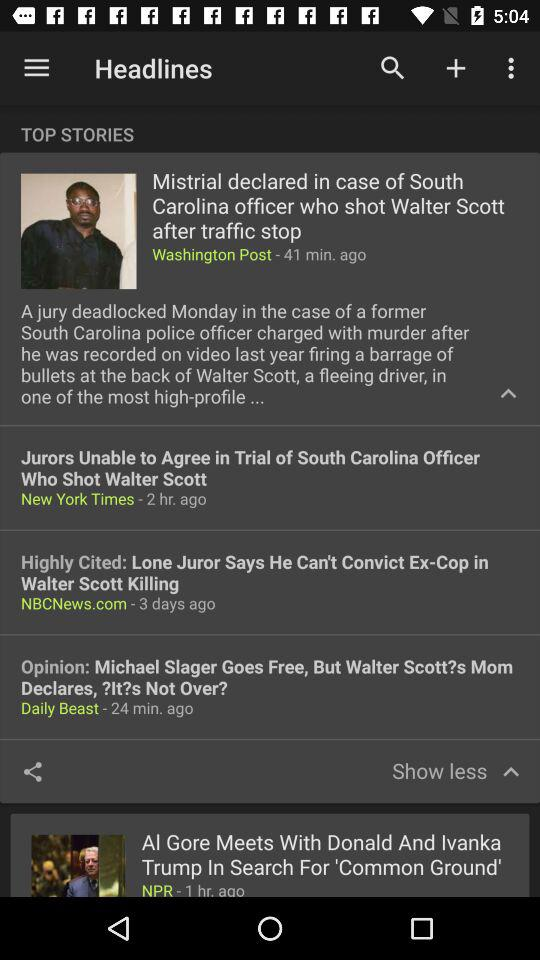Which post is highly cited?
When the provided information is insufficient, respond with <no answer>. <no answer> 